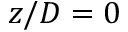Convert formula to latex. <formula><loc_0><loc_0><loc_500><loc_500>z / D = 0</formula> 